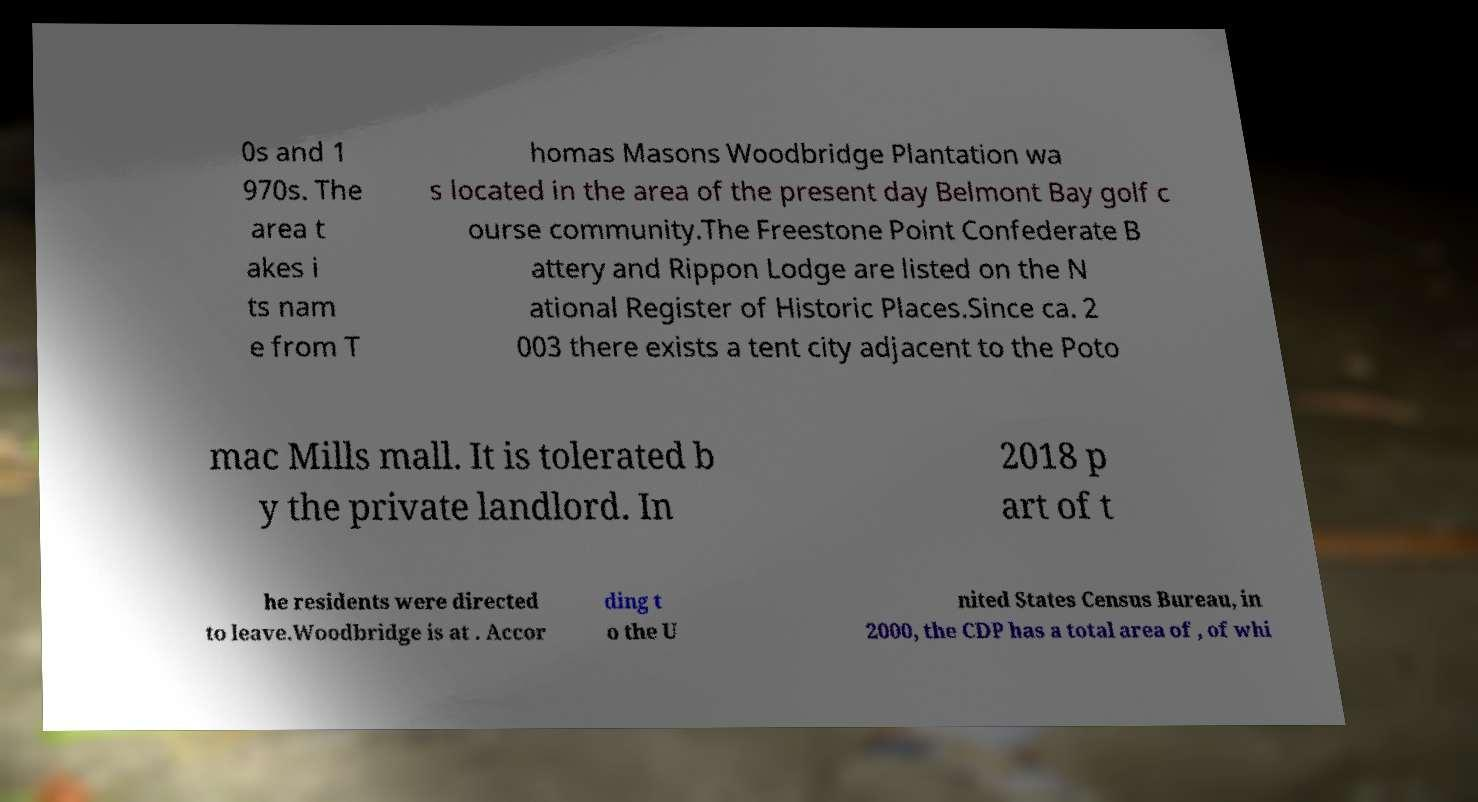Could you extract and type out the text from this image? 0s and 1 970s. The area t akes i ts nam e from T homas Masons Woodbridge Plantation wa s located in the area of the present day Belmont Bay golf c ourse community.The Freestone Point Confederate B attery and Rippon Lodge are listed on the N ational Register of Historic Places.Since ca. 2 003 there exists a tent city adjacent to the Poto mac Mills mall. It is tolerated b y the private landlord. In 2018 p art of t he residents were directed to leave.Woodbridge is at . Accor ding t o the U nited States Census Bureau, in 2000, the CDP has a total area of , of whi 